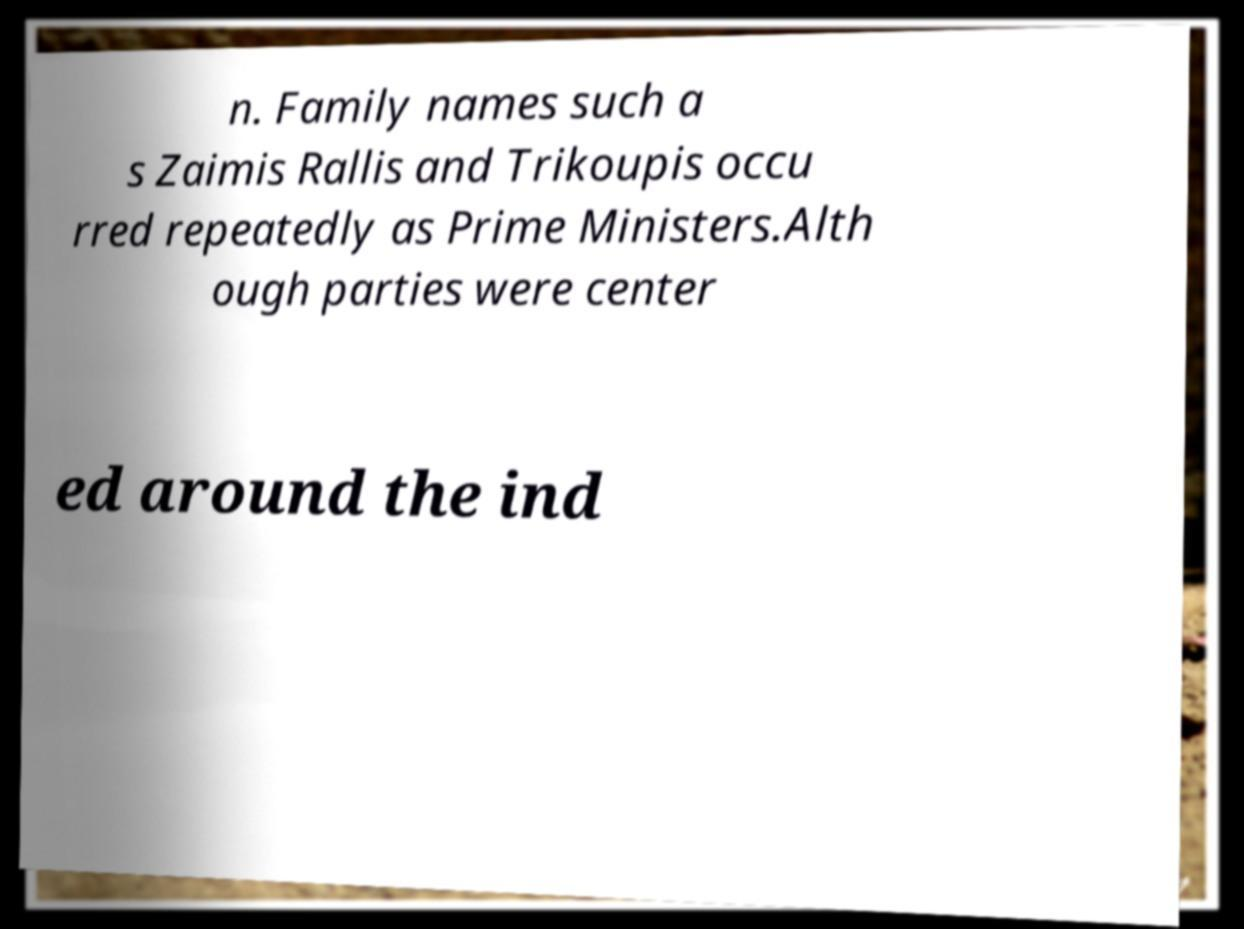Could you extract and type out the text from this image? n. Family names such a s Zaimis Rallis and Trikoupis occu rred repeatedly as Prime Ministers.Alth ough parties were center ed around the ind 